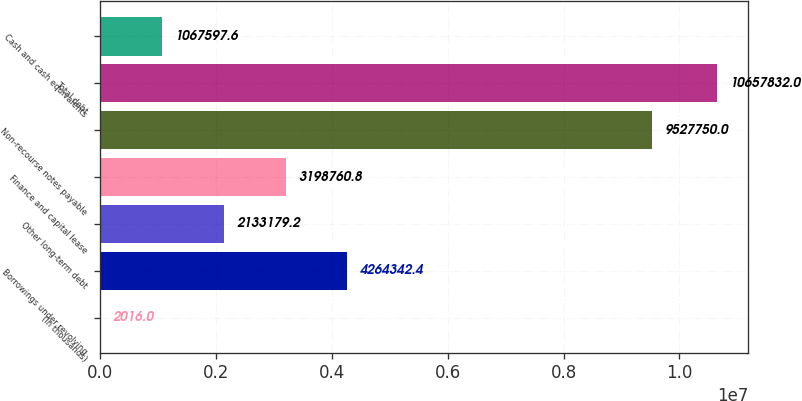Convert chart to OTSL. <chart><loc_0><loc_0><loc_500><loc_500><bar_chart><fcel>(In thousands)<fcel>Borrowings under revolving<fcel>Other long-term debt<fcel>Finance and capital lease<fcel>Non-recourse notes payable<fcel>Total debt<fcel>Cash and cash equivalents<nl><fcel>2016<fcel>4.26434e+06<fcel>2.13318e+06<fcel>3.19876e+06<fcel>9.52775e+06<fcel>1.06578e+07<fcel>1.0676e+06<nl></chart> 